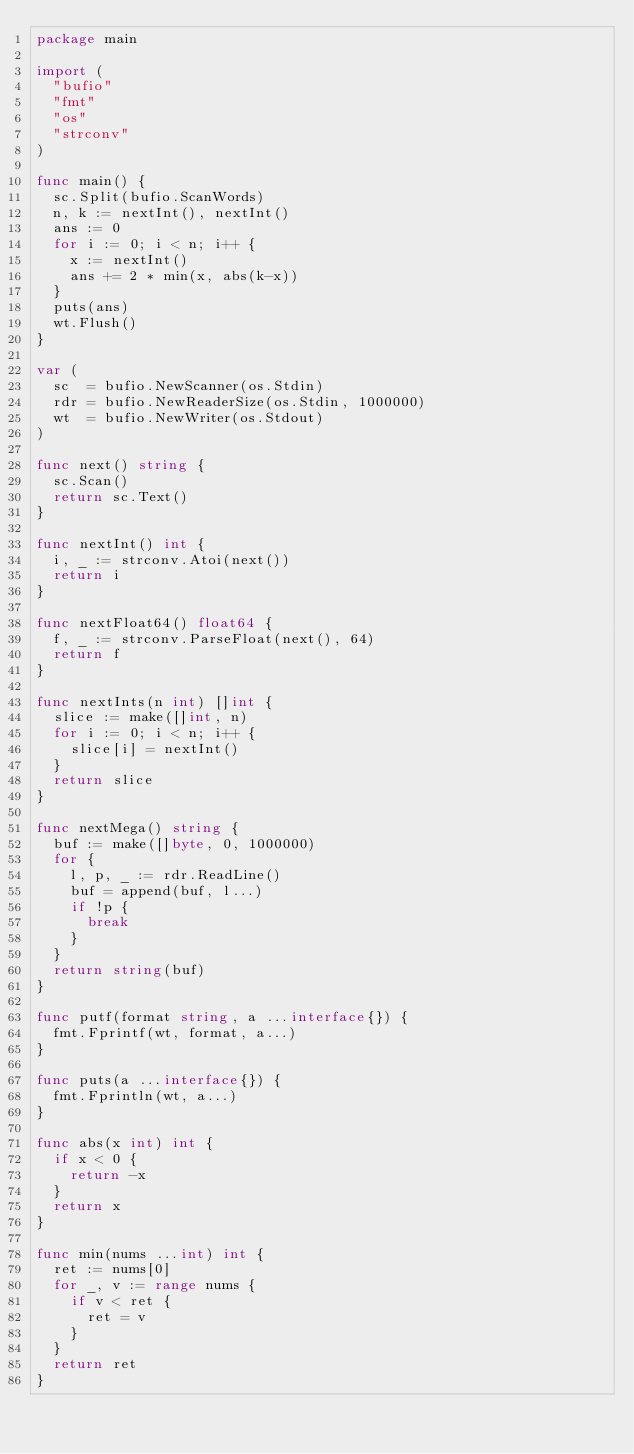Convert code to text. <code><loc_0><loc_0><loc_500><loc_500><_Go_>package main

import (
	"bufio"
	"fmt"
	"os"
	"strconv"
)

func main() {
	sc.Split(bufio.ScanWords)
	n, k := nextInt(), nextInt()
	ans := 0
	for i := 0; i < n; i++ {
		x := nextInt()
		ans += 2 * min(x, abs(k-x))
	}
	puts(ans)
	wt.Flush()
}

var (
	sc  = bufio.NewScanner(os.Stdin)
	rdr = bufio.NewReaderSize(os.Stdin, 1000000)
	wt  = bufio.NewWriter(os.Stdout)
)

func next() string {
	sc.Scan()
	return sc.Text()
}

func nextInt() int {
	i, _ := strconv.Atoi(next())
	return i
}

func nextFloat64() float64 {
	f, _ := strconv.ParseFloat(next(), 64)
	return f
}

func nextInts(n int) []int {
	slice := make([]int, n)
	for i := 0; i < n; i++ {
		slice[i] = nextInt()
	}
	return slice
}

func nextMega() string {
	buf := make([]byte, 0, 1000000)
	for {
		l, p, _ := rdr.ReadLine()
		buf = append(buf, l...)
		if !p {
			break
		}
	}
	return string(buf)
}

func putf(format string, a ...interface{}) {
	fmt.Fprintf(wt, format, a...)
}

func puts(a ...interface{}) {
	fmt.Fprintln(wt, a...)
}

func abs(x int) int {
	if x < 0 {
		return -x
	}
	return x
}

func min(nums ...int) int {
	ret := nums[0]
	for _, v := range nums {
		if v < ret {
			ret = v
		}
	}
	return ret
}
</code> 